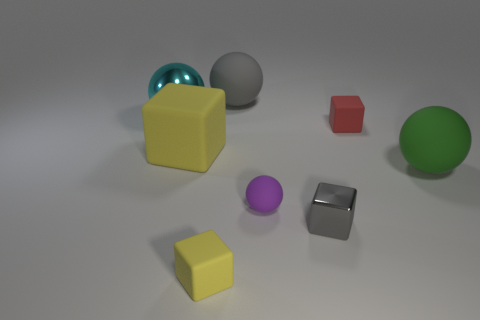Subtract 1 spheres. How many spheres are left? 3 Subtract all yellow balls. Subtract all red blocks. How many balls are left? 4 Add 1 yellow things. How many objects exist? 9 Subtract all small brown cylinders. Subtract all small blocks. How many objects are left? 5 Add 3 big metal balls. How many big metal balls are left? 4 Add 3 purple rubber balls. How many purple rubber balls exist? 4 Subtract 0 brown balls. How many objects are left? 8 